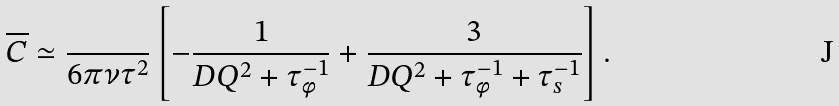<formula> <loc_0><loc_0><loc_500><loc_500>\overline { C } \simeq \frac { } { 6 \pi \nu \tau ^ { 2 } } \left [ - \frac { 1 } { D Q ^ { 2 } + \tau _ { \phi } ^ { - 1 } } + \frac { 3 } { D Q ^ { 2 } + \tau _ { \phi } ^ { - 1 } + \tau _ { s } ^ { - 1 } } \right ] .</formula> 